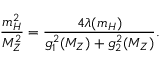<formula> <loc_0><loc_0><loc_500><loc_500>\frac { m _ { H } ^ { 2 } } { M _ { Z } ^ { 2 } } = \frac { 4 \lambda ( m _ { H } ) } { g _ { 1 } ^ { 2 } ( M _ { Z } ) + g _ { 2 } ^ { 2 } ( M _ { Z } ) } .</formula> 